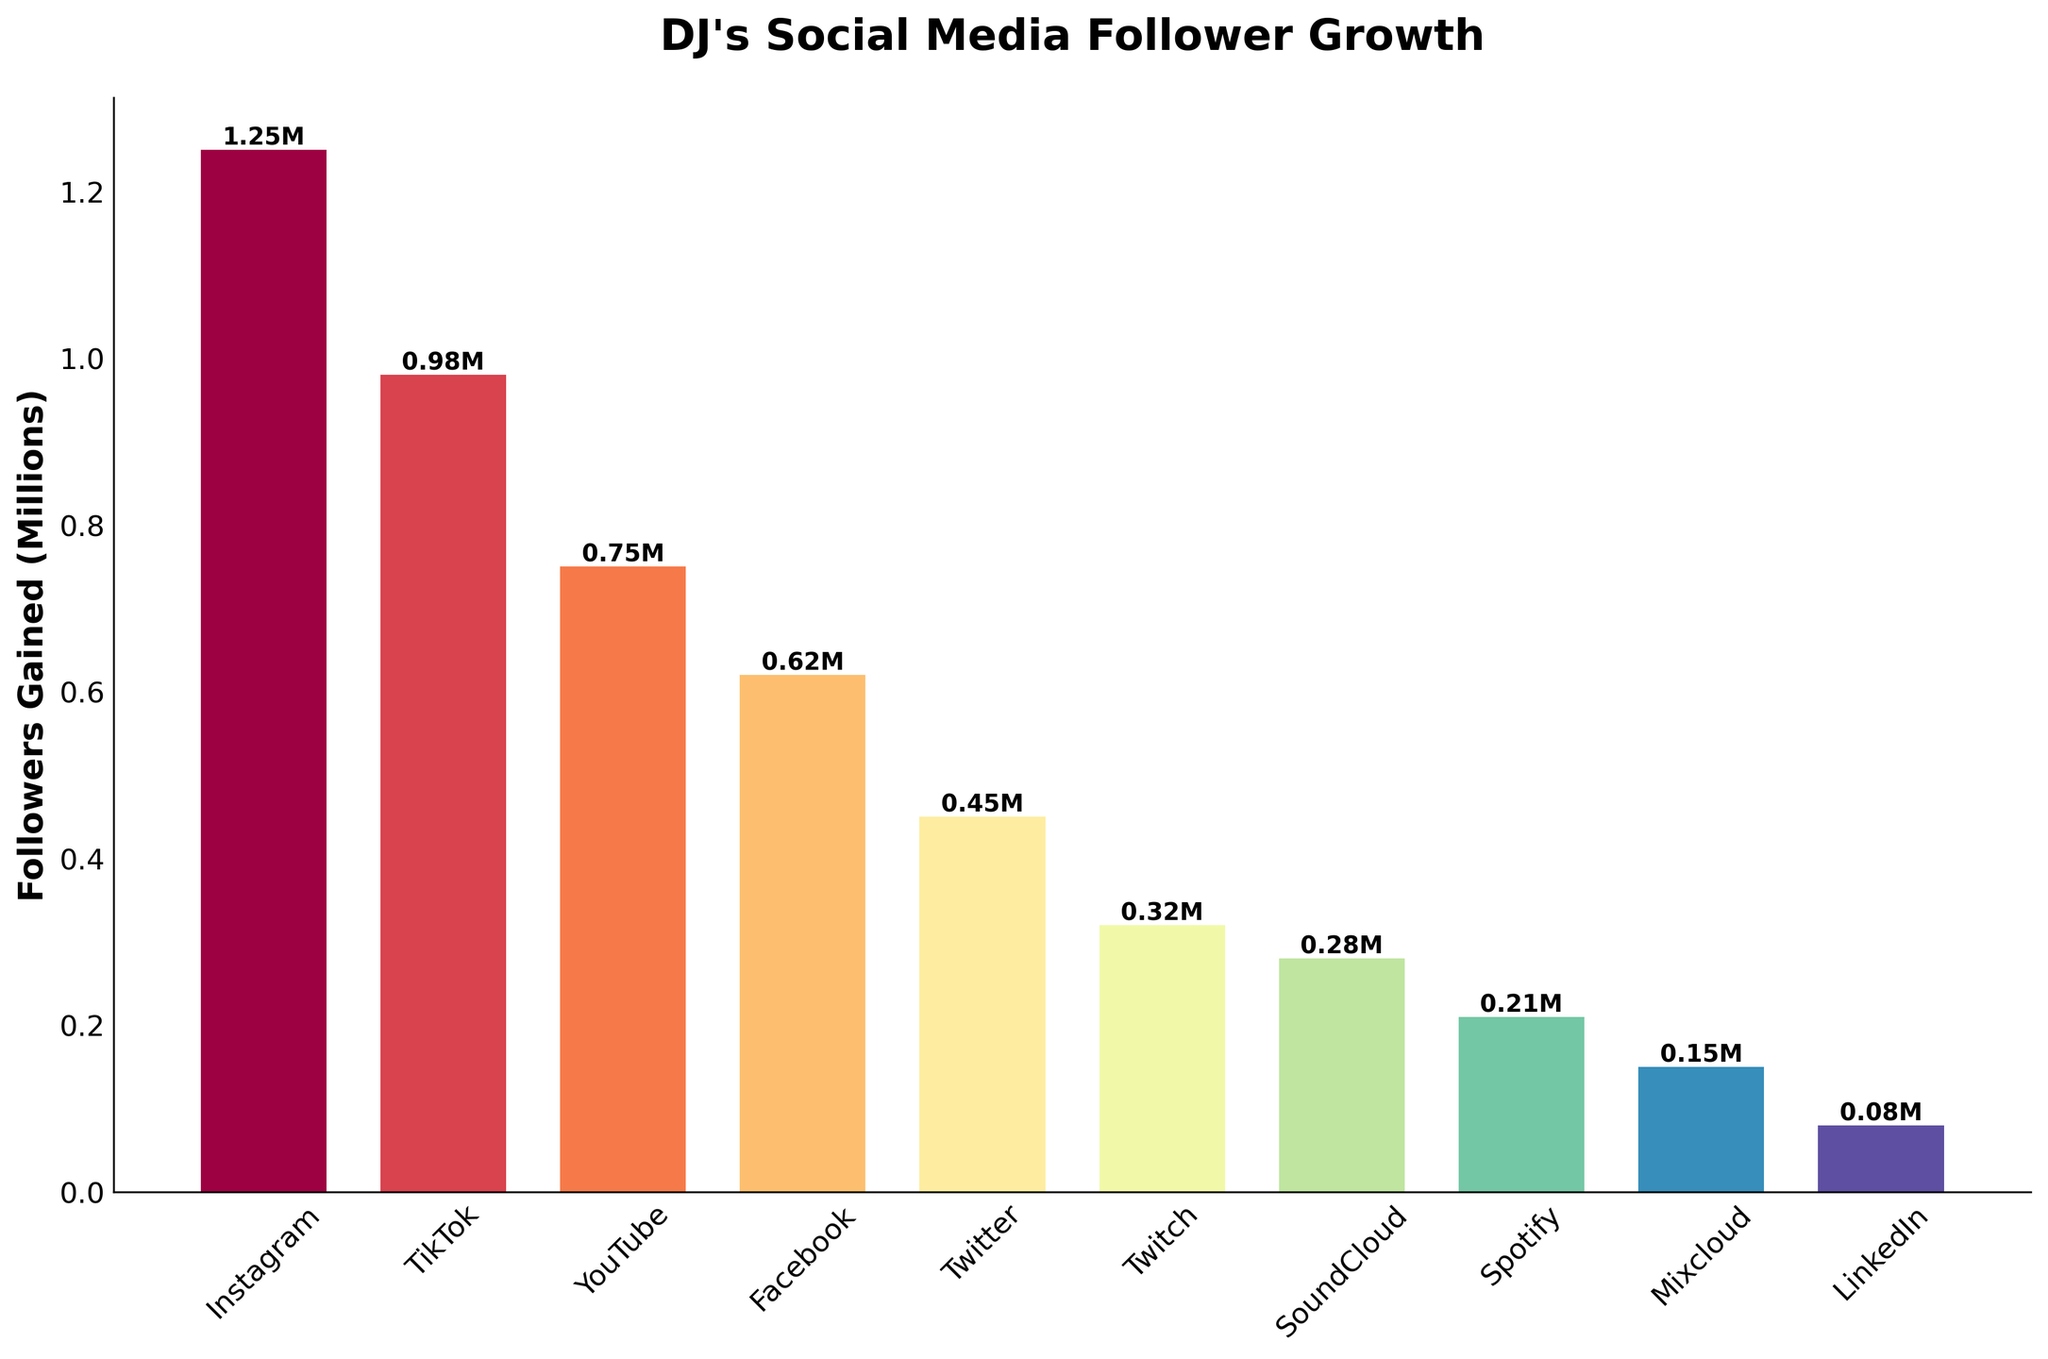What is the total follower growth across all platforms? To find the total follower growth, sum up the followers gained for each platform: 1,250,000 + 980,000 + 750,000 + 620,000 + 450,000 + 320,000 + 280,000 + 210,000 + 150,000 + 80,000 = 5,090,000.
Answer: 5,090,000 Which platform had the highest follower growth? By looking at the heights of the bars, Instagram has the tallest bar, indicating the highest follower growth of 1,250,000.
Answer: Instagram How much more followers did Instagram gain compared to TikTok? Subtract the followers gained by TikTok from Instagram: 1,250,000 - 980,000 = 270,000.
Answer: 270,000 Which platform had the lowest follower growth? The shortest bar belongs to LinkedIn with a follower growth of 80,000.
Answer: LinkedIn What is the average follower growth across all platforms? Sum up the followers gained by all platforms and then divide by the number of platforms: (1,250,000 + 980,000 + 750,000 + 620,000 + 450,000 + 320,000 + 280,000 + 210,000 + 150,000 + 80,000) / 10 = 509,000.
Answer: 509,000 Which platforms had follower growth less than 500,000? Identify the bars lower than the 0.5M mark: Twitter (450,000), Twitch (320,000), SoundCloud (280,000), Spotify (210,000), Mixcloud (150,000), and LinkedIn (80,000).
Answer: Twitter, Twitch, SoundCloud, Spotify, Mixcloud, LinkedIn By how much did YouTube's follower growth exceed Facebook’s? Subtract the followers gained by Facebook from YouTube: 750,000 - 620,000 = 130,000.
Answer: 130,000 If you combine the follower growth of SoundCloud and Mixcloud, how does it compare to TikTok's follower growth? Add SoundCloud (280,000) and Mixcloud (150,000) follower growth and compare it to TikTok's: 280,000 + 150,000 = 430,000, which is less than TikTok's 980,000.
Answer: Less than TikTok What percentage of the total follower growth did Instagram contribute? Calculate Instagram's contribution by dividing its growth by the total and then multiplying by 100: (1,250,000 / 5,090,000) * 100 ≈ 24.54%.
Answer: Approximately 24.54% How many platforms gained more than 500,000 followers? Count the bars higher than the 0.5M mark: Instagram (1,250,000), TikTok (980,000), YouTube (750,000), and Facebook (620,000), making it 4 platforms.
Answer: 4 